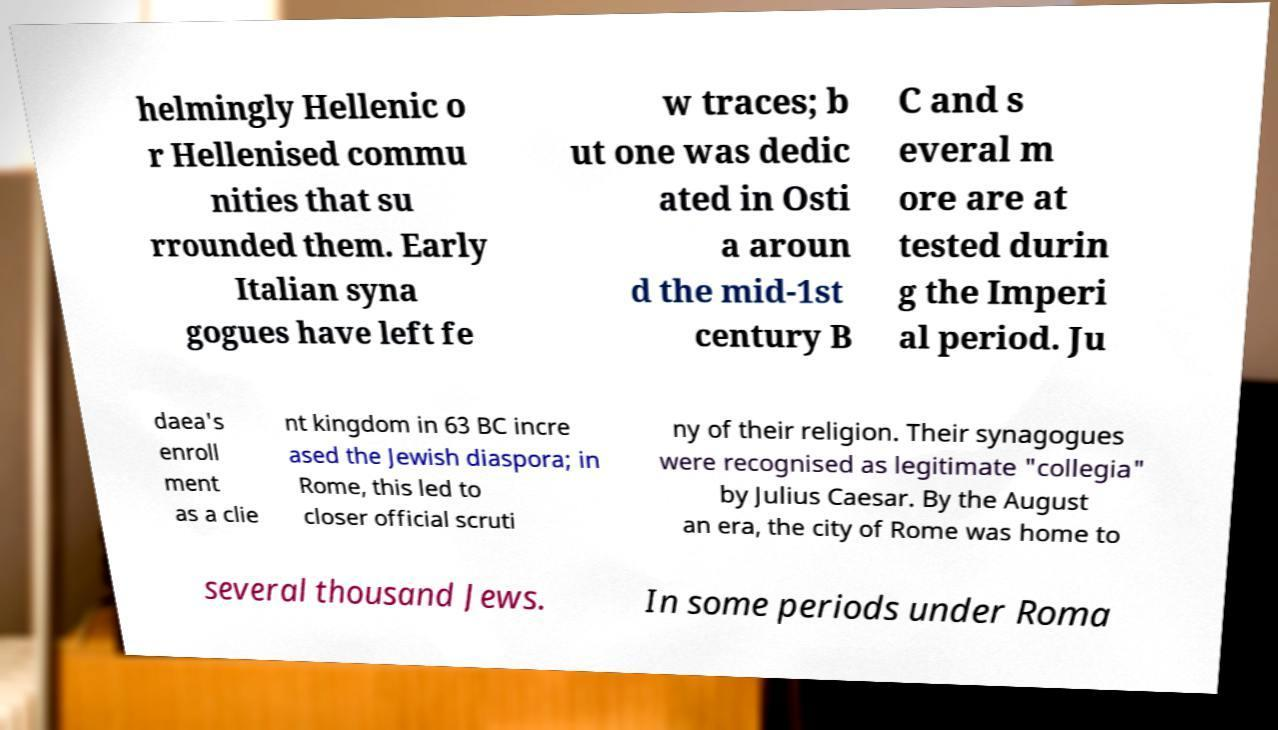For documentation purposes, I need the text within this image transcribed. Could you provide that? helmingly Hellenic o r Hellenised commu nities that su rrounded them. Early Italian syna gogues have left fe w traces; b ut one was dedic ated in Osti a aroun d the mid-1st century B C and s everal m ore are at tested durin g the Imperi al period. Ju daea's enroll ment as a clie nt kingdom in 63 BC incre ased the Jewish diaspora; in Rome, this led to closer official scruti ny of their religion. Their synagogues were recognised as legitimate "collegia" by Julius Caesar. By the August an era, the city of Rome was home to several thousand Jews. In some periods under Roma 